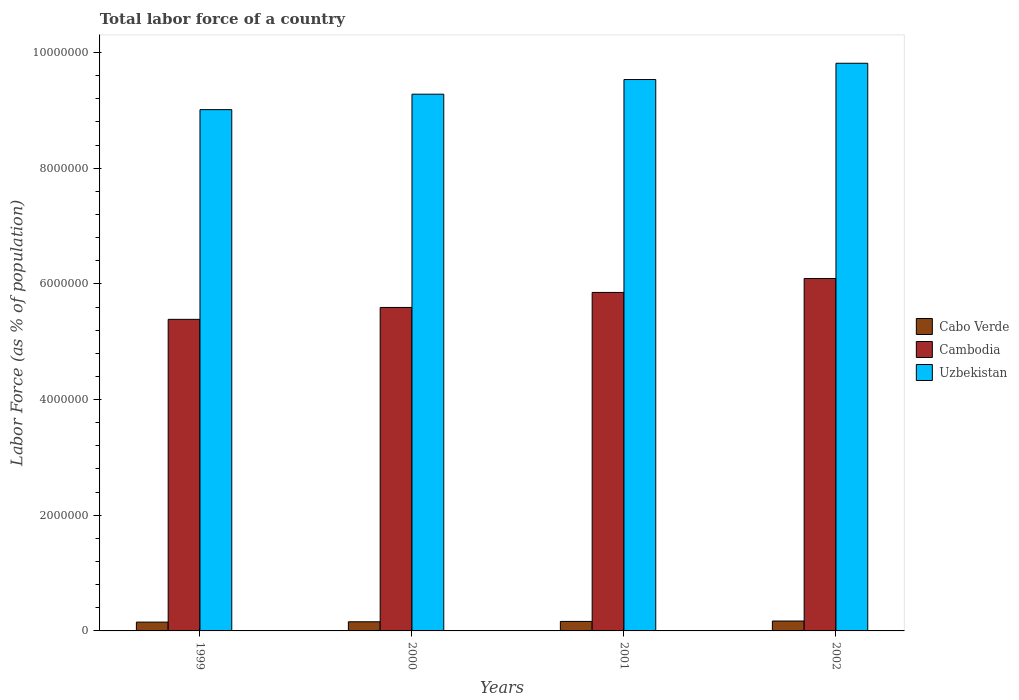How many groups of bars are there?
Offer a very short reply. 4. Are the number of bars on each tick of the X-axis equal?
Offer a very short reply. Yes. How many bars are there on the 2nd tick from the right?
Your response must be concise. 3. What is the label of the 4th group of bars from the left?
Your response must be concise. 2002. In how many cases, is the number of bars for a given year not equal to the number of legend labels?
Give a very brief answer. 0. What is the percentage of labor force in Cabo Verde in 2001?
Your response must be concise. 1.64e+05. Across all years, what is the maximum percentage of labor force in Cabo Verde?
Your answer should be compact. 1.71e+05. Across all years, what is the minimum percentage of labor force in Uzbekistan?
Offer a very short reply. 9.01e+06. In which year was the percentage of labor force in Uzbekistan maximum?
Your answer should be compact. 2002. In which year was the percentage of labor force in Cambodia minimum?
Provide a succinct answer. 1999. What is the total percentage of labor force in Cabo Verde in the graph?
Keep it short and to the point. 6.46e+05. What is the difference between the percentage of labor force in Cambodia in 1999 and that in 2001?
Make the answer very short. -4.66e+05. What is the difference between the percentage of labor force in Cambodia in 2000 and the percentage of labor force in Uzbekistan in 1999?
Your answer should be compact. -3.42e+06. What is the average percentage of labor force in Cabo Verde per year?
Provide a short and direct response. 1.62e+05. In the year 2000, what is the difference between the percentage of labor force in Uzbekistan and percentage of labor force in Cabo Verde?
Offer a terse response. 9.12e+06. In how many years, is the percentage of labor force in Cambodia greater than 4400000 %?
Offer a very short reply. 4. What is the ratio of the percentage of labor force in Cabo Verde in 1999 to that in 2002?
Your answer should be compact. 0.89. Is the difference between the percentage of labor force in Uzbekistan in 2000 and 2001 greater than the difference between the percentage of labor force in Cabo Verde in 2000 and 2001?
Your answer should be compact. No. What is the difference between the highest and the second highest percentage of labor force in Uzbekistan?
Your answer should be very brief. 2.81e+05. What is the difference between the highest and the lowest percentage of labor force in Cambodia?
Offer a terse response. 7.06e+05. Is the sum of the percentage of labor force in Cambodia in 1999 and 2000 greater than the maximum percentage of labor force in Cabo Verde across all years?
Provide a succinct answer. Yes. What does the 3rd bar from the left in 2002 represents?
Offer a terse response. Uzbekistan. What does the 3rd bar from the right in 2001 represents?
Your answer should be very brief. Cabo Verde. Are all the bars in the graph horizontal?
Your answer should be compact. No. Does the graph contain grids?
Offer a terse response. No. How many legend labels are there?
Ensure brevity in your answer.  3. How are the legend labels stacked?
Provide a short and direct response. Vertical. What is the title of the graph?
Your response must be concise. Total labor force of a country. What is the label or title of the X-axis?
Your answer should be compact. Years. What is the label or title of the Y-axis?
Offer a terse response. Labor Force (as % of population). What is the Labor Force (as % of population) of Cabo Verde in 1999?
Your response must be concise. 1.53e+05. What is the Labor Force (as % of population) in Cambodia in 1999?
Offer a very short reply. 5.39e+06. What is the Labor Force (as % of population) in Uzbekistan in 1999?
Keep it short and to the point. 9.01e+06. What is the Labor Force (as % of population) in Cabo Verde in 2000?
Give a very brief answer. 1.58e+05. What is the Labor Force (as % of population) of Cambodia in 2000?
Ensure brevity in your answer.  5.59e+06. What is the Labor Force (as % of population) in Uzbekistan in 2000?
Offer a terse response. 9.28e+06. What is the Labor Force (as % of population) of Cabo Verde in 2001?
Give a very brief answer. 1.64e+05. What is the Labor Force (as % of population) of Cambodia in 2001?
Your answer should be very brief. 5.85e+06. What is the Labor Force (as % of population) of Uzbekistan in 2001?
Offer a very short reply. 9.53e+06. What is the Labor Force (as % of population) in Cabo Verde in 2002?
Keep it short and to the point. 1.71e+05. What is the Labor Force (as % of population) of Cambodia in 2002?
Your response must be concise. 6.09e+06. What is the Labor Force (as % of population) of Uzbekistan in 2002?
Your answer should be compact. 9.81e+06. Across all years, what is the maximum Labor Force (as % of population) in Cabo Verde?
Give a very brief answer. 1.71e+05. Across all years, what is the maximum Labor Force (as % of population) of Cambodia?
Your answer should be compact. 6.09e+06. Across all years, what is the maximum Labor Force (as % of population) in Uzbekistan?
Provide a succinct answer. 9.81e+06. Across all years, what is the minimum Labor Force (as % of population) of Cabo Verde?
Offer a terse response. 1.53e+05. Across all years, what is the minimum Labor Force (as % of population) in Cambodia?
Offer a very short reply. 5.39e+06. Across all years, what is the minimum Labor Force (as % of population) of Uzbekistan?
Make the answer very short. 9.01e+06. What is the total Labor Force (as % of population) of Cabo Verde in the graph?
Your answer should be compact. 6.46e+05. What is the total Labor Force (as % of population) of Cambodia in the graph?
Offer a very short reply. 2.29e+07. What is the total Labor Force (as % of population) of Uzbekistan in the graph?
Your response must be concise. 3.76e+07. What is the difference between the Labor Force (as % of population) in Cabo Verde in 1999 and that in 2000?
Provide a short and direct response. -5509. What is the difference between the Labor Force (as % of population) in Cambodia in 1999 and that in 2000?
Your answer should be very brief. -2.06e+05. What is the difference between the Labor Force (as % of population) of Uzbekistan in 1999 and that in 2000?
Ensure brevity in your answer.  -2.67e+05. What is the difference between the Labor Force (as % of population) in Cabo Verde in 1999 and that in 2001?
Provide a succinct answer. -1.19e+04. What is the difference between the Labor Force (as % of population) in Cambodia in 1999 and that in 2001?
Your answer should be compact. -4.66e+05. What is the difference between the Labor Force (as % of population) of Uzbekistan in 1999 and that in 2001?
Provide a short and direct response. -5.21e+05. What is the difference between the Labor Force (as % of population) of Cabo Verde in 1999 and that in 2002?
Offer a terse response. -1.86e+04. What is the difference between the Labor Force (as % of population) of Cambodia in 1999 and that in 2002?
Your answer should be compact. -7.06e+05. What is the difference between the Labor Force (as % of population) in Uzbekistan in 1999 and that in 2002?
Ensure brevity in your answer.  -8.02e+05. What is the difference between the Labor Force (as % of population) in Cabo Verde in 2000 and that in 2001?
Your response must be concise. -6390. What is the difference between the Labor Force (as % of population) of Cambodia in 2000 and that in 2001?
Your response must be concise. -2.60e+05. What is the difference between the Labor Force (as % of population) of Uzbekistan in 2000 and that in 2001?
Your answer should be compact. -2.54e+05. What is the difference between the Labor Force (as % of population) of Cabo Verde in 2000 and that in 2002?
Offer a very short reply. -1.31e+04. What is the difference between the Labor Force (as % of population) in Cambodia in 2000 and that in 2002?
Provide a short and direct response. -5.01e+05. What is the difference between the Labor Force (as % of population) in Uzbekistan in 2000 and that in 2002?
Provide a succinct answer. -5.35e+05. What is the difference between the Labor Force (as % of population) of Cabo Verde in 2001 and that in 2002?
Your answer should be compact. -6705. What is the difference between the Labor Force (as % of population) of Cambodia in 2001 and that in 2002?
Ensure brevity in your answer.  -2.41e+05. What is the difference between the Labor Force (as % of population) in Uzbekistan in 2001 and that in 2002?
Keep it short and to the point. -2.81e+05. What is the difference between the Labor Force (as % of population) in Cabo Verde in 1999 and the Labor Force (as % of population) in Cambodia in 2000?
Give a very brief answer. -5.44e+06. What is the difference between the Labor Force (as % of population) of Cabo Verde in 1999 and the Labor Force (as % of population) of Uzbekistan in 2000?
Make the answer very short. -9.13e+06. What is the difference between the Labor Force (as % of population) in Cambodia in 1999 and the Labor Force (as % of population) in Uzbekistan in 2000?
Give a very brief answer. -3.89e+06. What is the difference between the Labor Force (as % of population) of Cabo Verde in 1999 and the Labor Force (as % of population) of Cambodia in 2001?
Give a very brief answer. -5.70e+06. What is the difference between the Labor Force (as % of population) of Cabo Verde in 1999 and the Labor Force (as % of population) of Uzbekistan in 2001?
Offer a terse response. -9.38e+06. What is the difference between the Labor Force (as % of population) in Cambodia in 1999 and the Labor Force (as % of population) in Uzbekistan in 2001?
Ensure brevity in your answer.  -4.15e+06. What is the difference between the Labor Force (as % of population) in Cabo Verde in 1999 and the Labor Force (as % of population) in Cambodia in 2002?
Your response must be concise. -5.94e+06. What is the difference between the Labor Force (as % of population) in Cabo Verde in 1999 and the Labor Force (as % of population) in Uzbekistan in 2002?
Your answer should be very brief. -9.66e+06. What is the difference between the Labor Force (as % of population) in Cambodia in 1999 and the Labor Force (as % of population) in Uzbekistan in 2002?
Offer a very short reply. -4.43e+06. What is the difference between the Labor Force (as % of population) of Cabo Verde in 2000 and the Labor Force (as % of population) of Cambodia in 2001?
Offer a very short reply. -5.69e+06. What is the difference between the Labor Force (as % of population) in Cabo Verde in 2000 and the Labor Force (as % of population) in Uzbekistan in 2001?
Keep it short and to the point. -9.37e+06. What is the difference between the Labor Force (as % of population) in Cambodia in 2000 and the Labor Force (as % of population) in Uzbekistan in 2001?
Keep it short and to the point. -3.94e+06. What is the difference between the Labor Force (as % of population) of Cabo Verde in 2000 and the Labor Force (as % of population) of Cambodia in 2002?
Your response must be concise. -5.93e+06. What is the difference between the Labor Force (as % of population) in Cabo Verde in 2000 and the Labor Force (as % of population) in Uzbekistan in 2002?
Your response must be concise. -9.66e+06. What is the difference between the Labor Force (as % of population) in Cambodia in 2000 and the Labor Force (as % of population) in Uzbekistan in 2002?
Ensure brevity in your answer.  -4.22e+06. What is the difference between the Labor Force (as % of population) in Cabo Verde in 2001 and the Labor Force (as % of population) in Cambodia in 2002?
Your response must be concise. -5.93e+06. What is the difference between the Labor Force (as % of population) of Cabo Verde in 2001 and the Labor Force (as % of population) of Uzbekistan in 2002?
Your answer should be compact. -9.65e+06. What is the difference between the Labor Force (as % of population) of Cambodia in 2001 and the Labor Force (as % of population) of Uzbekistan in 2002?
Offer a very short reply. -3.96e+06. What is the average Labor Force (as % of population) in Cabo Verde per year?
Your response must be concise. 1.62e+05. What is the average Labor Force (as % of population) of Cambodia per year?
Your response must be concise. 5.73e+06. What is the average Labor Force (as % of population) in Uzbekistan per year?
Provide a short and direct response. 9.41e+06. In the year 1999, what is the difference between the Labor Force (as % of population) in Cabo Verde and Labor Force (as % of population) in Cambodia?
Give a very brief answer. -5.23e+06. In the year 1999, what is the difference between the Labor Force (as % of population) of Cabo Verde and Labor Force (as % of population) of Uzbekistan?
Provide a short and direct response. -8.86e+06. In the year 1999, what is the difference between the Labor Force (as % of population) in Cambodia and Labor Force (as % of population) in Uzbekistan?
Your answer should be compact. -3.63e+06. In the year 2000, what is the difference between the Labor Force (as % of population) in Cabo Verde and Labor Force (as % of population) in Cambodia?
Offer a very short reply. -5.43e+06. In the year 2000, what is the difference between the Labor Force (as % of population) of Cabo Verde and Labor Force (as % of population) of Uzbekistan?
Provide a succinct answer. -9.12e+06. In the year 2000, what is the difference between the Labor Force (as % of population) of Cambodia and Labor Force (as % of population) of Uzbekistan?
Offer a terse response. -3.69e+06. In the year 2001, what is the difference between the Labor Force (as % of population) of Cabo Verde and Labor Force (as % of population) of Cambodia?
Keep it short and to the point. -5.69e+06. In the year 2001, what is the difference between the Labor Force (as % of population) in Cabo Verde and Labor Force (as % of population) in Uzbekistan?
Offer a terse response. -9.37e+06. In the year 2001, what is the difference between the Labor Force (as % of population) of Cambodia and Labor Force (as % of population) of Uzbekistan?
Ensure brevity in your answer.  -3.68e+06. In the year 2002, what is the difference between the Labor Force (as % of population) of Cabo Verde and Labor Force (as % of population) of Cambodia?
Keep it short and to the point. -5.92e+06. In the year 2002, what is the difference between the Labor Force (as % of population) in Cabo Verde and Labor Force (as % of population) in Uzbekistan?
Your response must be concise. -9.64e+06. In the year 2002, what is the difference between the Labor Force (as % of population) in Cambodia and Labor Force (as % of population) in Uzbekistan?
Provide a short and direct response. -3.72e+06. What is the ratio of the Labor Force (as % of population) of Cabo Verde in 1999 to that in 2000?
Provide a short and direct response. 0.97. What is the ratio of the Labor Force (as % of population) in Cambodia in 1999 to that in 2000?
Give a very brief answer. 0.96. What is the ratio of the Labor Force (as % of population) in Uzbekistan in 1999 to that in 2000?
Make the answer very short. 0.97. What is the ratio of the Labor Force (as % of population) in Cabo Verde in 1999 to that in 2001?
Provide a succinct answer. 0.93. What is the ratio of the Labor Force (as % of population) of Cambodia in 1999 to that in 2001?
Keep it short and to the point. 0.92. What is the ratio of the Labor Force (as % of population) in Uzbekistan in 1999 to that in 2001?
Ensure brevity in your answer.  0.95. What is the ratio of the Labor Force (as % of population) of Cabo Verde in 1999 to that in 2002?
Ensure brevity in your answer.  0.89. What is the ratio of the Labor Force (as % of population) of Cambodia in 1999 to that in 2002?
Your answer should be compact. 0.88. What is the ratio of the Labor Force (as % of population) in Uzbekistan in 1999 to that in 2002?
Provide a succinct answer. 0.92. What is the ratio of the Labor Force (as % of population) in Cabo Verde in 2000 to that in 2001?
Provide a succinct answer. 0.96. What is the ratio of the Labor Force (as % of population) of Cambodia in 2000 to that in 2001?
Provide a short and direct response. 0.96. What is the ratio of the Labor Force (as % of population) in Uzbekistan in 2000 to that in 2001?
Make the answer very short. 0.97. What is the ratio of the Labor Force (as % of population) of Cabo Verde in 2000 to that in 2002?
Ensure brevity in your answer.  0.92. What is the ratio of the Labor Force (as % of population) in Cambodia in 2000 to that in 2002?
Give a very brief answer. 0.92. What is the ratio of the Labor Force (as % of population) in Uzbekistan in 2000 to that in 2002?
Provide a short and direct response. 0.95. What is the ratio of the Labor Force (as % of population) in Cabo Verde in 2001 to that in 2002?
Your response must be concise. 0.96. What is the ratio of the Labor Force (as % of population) of Cambodia in 2001 to that in 2002?
Ensure brevity in your answer.  0.96. What is the ratio of the Labor Force (as % of population) in Uzbekistan in 2001 to that in 2002?
Provide a succinct answer. 0.97. What is the difference between the highest and the second highest Labor Force (as % of population) of Cabo Verde?
Give a very brief answer. 6705. What is the difference between the highest and the second highest Labor Force (as % of population) of Cambodia?
Offer a terse response. 2.41e+05. What is the difference between the highest and the second highest Labor Force (as % of population) in Uzbekistan?
Offer a terse response. 2.81e+05. What is the difference between the highest and the lowest Labor Force (as % of population) in Cabo Verde?
Make the answer very short. 1.86e+04. What is the difference between the highest and the lowest Labor Force (as % of population) in Cambodia?
Ensure brevity in your answer.  7.06e+05. What is the difference between the highest and the lowest Labor Force (as % of population) of Uzbekistan?
Your answer should be very brief. 8.02e+05. 